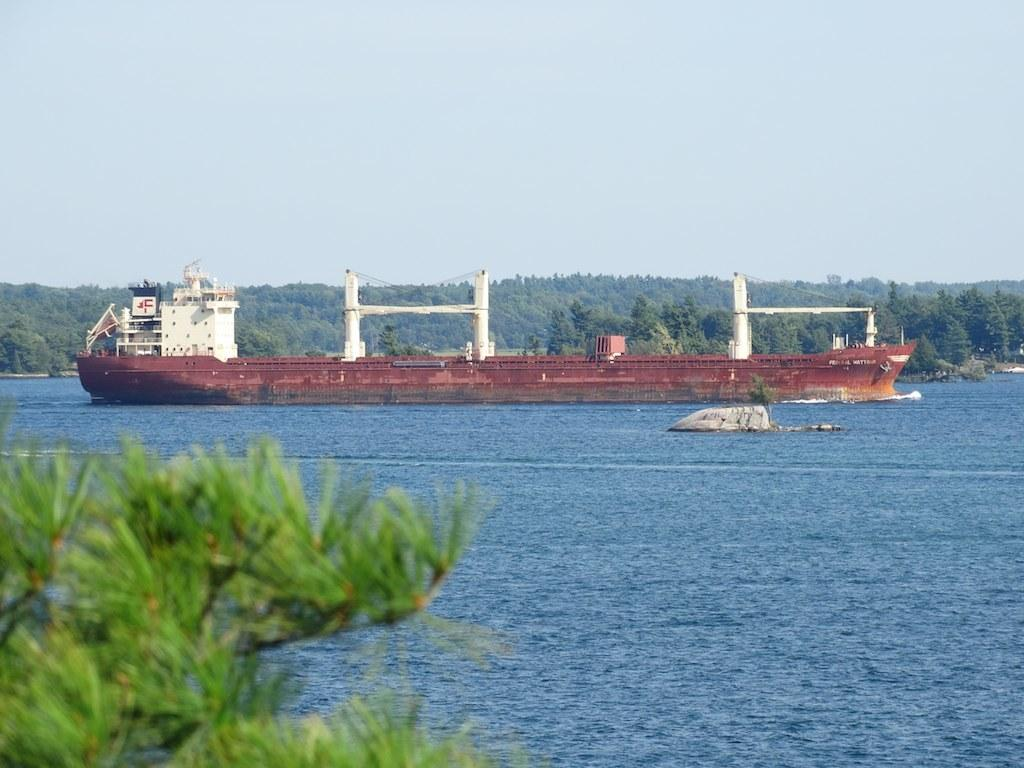What is the main subject of the image? The main subject of the image is a ship. Where is the ship located? The ship is on water. What can be seen in the background of the image? There are trees and the sky visible in the background of the image. How much sugar is dissolving in the water around the ship? There is no sugar present in the image, and therefore no sugar can be observed dissolving in the water. 